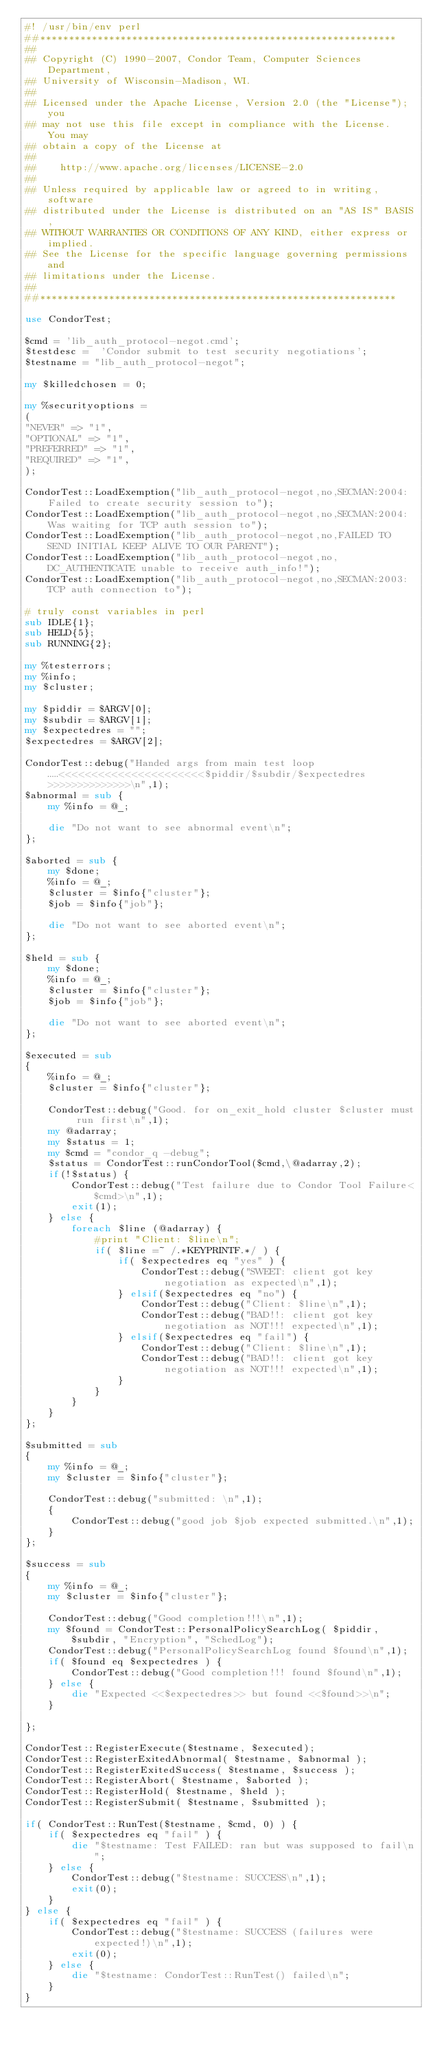<code> <loc_0><loc_0><loc_500><loc_500><_Perl_>#! /usr/bin/env perl
##**************************************************************
##
## Copyright (C) 1990-2007, Condor Team, Computer Sciences Department,
## University of Wisconsin-Madison, WI.
## 
## Licensed under the Apache License, Version 2.0 (the "License"); you
## may not use this file except in compliance with the License.  You may
## obtain a copy of the License at
## 
##    http://www.apache.org/licenses/LICENSE-2.0
## 
## Unless required by applicable law or agreed to in writing, software
## distributed under the License is distributed on an "AS IS" BASIS,
## WITHOUT WARRANTIES OR CONDITIONS OF ANY KIND, either express or implied.
## See the License for the specific language governing permissions and
## limitations under the License.
##
##**************************************************************

use CondorTest;

$cmd = 'lib_auth_protocol-negot.cmd';
$testdesc =  'Condor submit to test security negotiations';
$testname = "lib_auth_protocol-negot";

my $killedchosen = 0;

my %securityoptions =
(
"NEVER" => "1",
"OPTIONAL" => "1",
"PREFERRED" => "1",
"REQUIRED" => "1",
);

CondorTest::LoadExemption("lib_auth_protocol-negot,no,SECMAN:2004:Failed to create security session to");
CondorTest::LoadExemption("lib_auth_protocol-negot,no,SECMAN:2004:Was waiting for TCP auth session to");
CondorTest::LoadExemption("lib_auth_protocol-negot,no,FAILED TO SEND INITIAL KEEP ALIVE TO OUR PARENT");
CondorTest::LoadExemption("lib_auth_protocol-negot,no,DC_AUTHENTICATE unable to receive auth_info!");
CondorTest::LoadExemption("lib_auth_protocol-negot,no,SECMAN:2003:TCP auth connection to");

# truly const variables in perl
sub IDLE{1};
sub HELD{5};
sub RUNNING{2};

my %testerrors;
my %info;
my $cluster;

my $piddir = $ARGV[0];
my $subdir = $ARGV[1];
my $expectedres = "";
$expectedres = $ARGV[2];

CondorTest::debug("Handed args from main test loop.....<<<<<<<<<<<<<<<<<<<<<<$piddir/$subdir/$expectedres>>>>>>>>>>>>>>\n",1);
$abnormal = sub {
	my %info = @_;

	die "Do not want to see abnormal event\n";
};

$aborted = sub {
	my $done;
	%info = @_;
	$cluster = $info{"cluster"};
	$job = $info{"job"};

	die "Do not want to see aborted event\n";
};

$held = sub {
	my $done;
	%info = @_;
	$cluster = $info{"cluster"};
	$job = $info{"job"};

	die "Do not want to see aborted event\n";
};

$executed = sub
{
	%info = @_;
	$cluster = $info{"cluster"};

	CondorTest::debug("Good. for on_exit_hold cluster $cluster must run first\n",1);
	my @adarray;
	my $status = 1;
	my $cmd = "condor_q -debug";
	$status = CondorTest::runCondorTool($cmd,\@adarray,2);
	if(!$status) {
		CondorTest::debug("Test failure due to Condor Tool Failure<$cmd>\n",1);
		exit(1);
	} else {
		foreach $line (@adarray) {
			#print "Client: $line\n";
			if( $line =~ /.*KEYPRINTF.*/ ) {
				if( $expectedres eq "yes" ) {
					CondorTest::debug("SWEET: client got key negotiation as expected\n",1);
				} elsif($expectedres eq "no") {
					CondorTest::debug("Client: $line\n",1);
					CondorTest::debug("BAD!!: client got key negotiation as NOT!!! expected\n",1);
				} elsif($expectedres eq "fail") {
					CondorTest::debug("Client: $line\n",1);
					CondorTest::debug("BAD!!: client got key negotiation as NOT!!! expected\n",1);
				}
			}
		}
	}
};

$submitted = sub
{
	my %info = @_;
	my $cluster = $info{"cluster"};

	CondorTest::debug("submitted: \n",1);
	{
		CondorTest::debug("good job $job expected submitted.\n",1);
	}
};

$success = sub
{
	my %info = @_;
	my $cluster = $info{"cluster"};

	CondorTest::debug("Good completion!!!\n",1);
	my $found = CondorTest::PersonalPolicySearchLog( $piddir, $subdir, "Encryption", "SchedLog");
	CondorTest::debug("PersonalPolicySearchLog found $found\n",1);
	if( $found eq $expectedres ) {
		CondorTest::debug("Good completion!!! found $found\n",1);
	} else {
		die "Expected <<$expectedres>> but found <<$found>>\n";
	}

};

CondorTest::RegisterExecute($testname, $executed);
CondorTest::RegisterExitedAbnormal( $testname, $abnormal );
CondorTest::RegisterExitedSuccess( $testname, $success );
CondorTest::RegisterAbort( $testname, $aborted );
CondorTest::RegisterHold( $testname, $held );
CondorTest::RegisterSubmit( $testname, $submitted );

if( CondorTest::RunTest($testname, $cmd, 0) ) {
	if( $expectedres eq "fail" ) {
		die "$testname: Test FAILED: ran but was supposed to fail\n";
	} else {
		CondorTest::debug("$testname: SUCCESS\n",1);
		exit(0);
	}
} else {
	if( $expectedres eq "fail" ) {
		CondorTest::debug("$testname: SUCCESS (failures were expected!)\n",1);
		exit(0);
	} else {
		die "$testname: CondorTest::RunTest() failed\n";
	}
}

</code> 